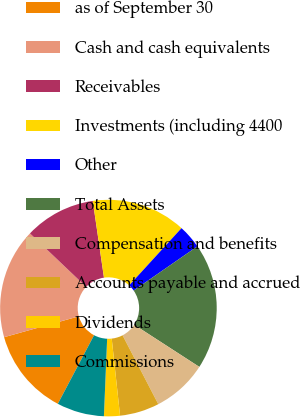Convert chart. <chart><loc_0><loc_0><loc_500><loc_500><pie_chart><fcel>as of September 30<fcel>Cash and cash equivalents<fcel>Receivables<fcel>Investments (including 4400<fcel>Other<fcel>Total Assets<fcel>Compensation and benefits<fcel>Accounts payable and accrued<fcel>Dividends<fcel>Commissions<nl><fcel>12.93%<fcel>16.44%<fcel>10.59%<fcel>14.1%<fcel>3.56%<fcel>18.79%<fcel>8.24%<fcel>5.9%<fcel>2.38%<fcel>7.07%<nl></chart> 